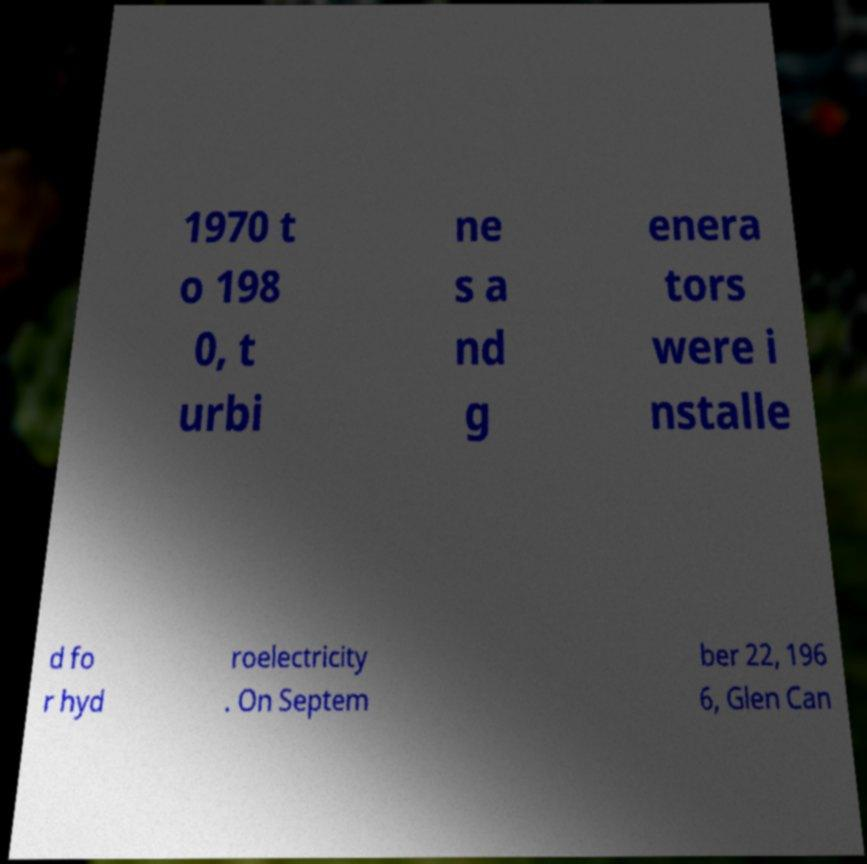Please read and relay the text visible in this image. What does it say? 1970 t o 198 0, t urbi ne s a nd g enera tors were i nstalle d fo r hyd roelectricity . On Septem ber 22, 196 6, Glen Can 